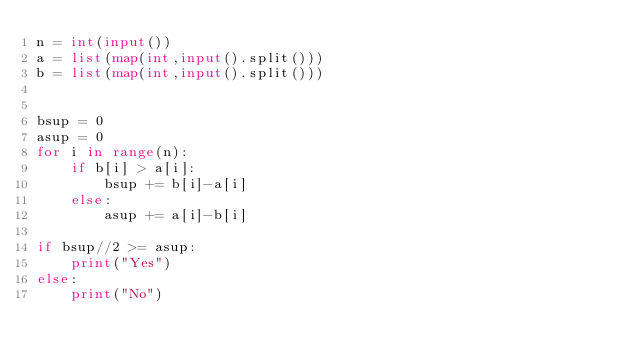<code> <loc_0><loc_0><loc_500><loc_500><_Python_>n = int(input())
a = list(map(int,input().split()))
b = list(map(int,input().split()))


bsup = 0
asup = 0
for i in range(n):
    if b[i] > a[i]:
        bsup += b[i]-a[i]
    else:
        asup += a[i]-b[i]

if bsup//2 >= asup:
    print("Yes")
else:
    print("No")</code> 